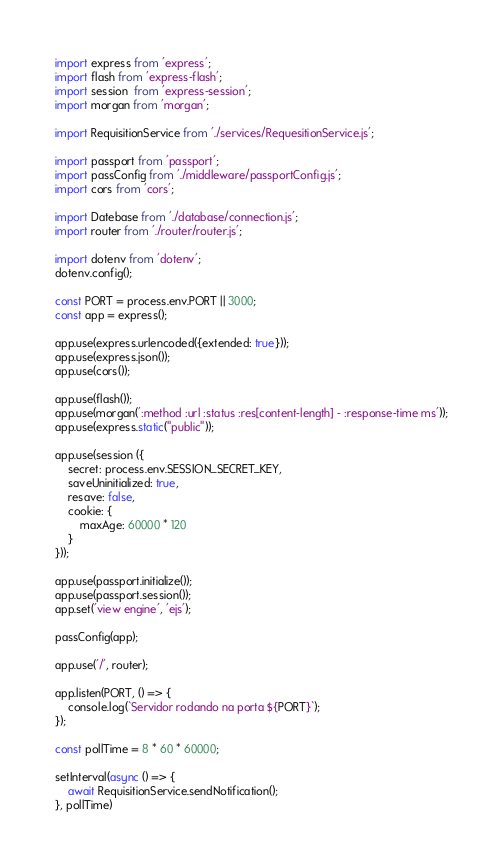<code> <loc_0><loc_0><loc_500><loc_500><_JavaScript_>import express from 'express';
import flash from 'express-flash';
import session  from 'express-session';
import morgan from 'morgan';

import RequisitionService from './services/RequesitionService.js';

import passport from 'passport';
import passConfig from './middleware/passportConfig.js';
import cors from 'cors';

import Datebase from './database/connection.js';
import router from './router/router.js';

import dotenv from 'dotenv';
dotenv.config();

const PORT = process.env.PORT || 3000;
const app = express();

app.use(express.urlencoded({extended: true}));
app.use(express.json());
app.use(cors());

app.use(flash());
app.use(morgan(':method :url :status :res[content-length] - :response-time ms'));
app.use(express.static("public"));

app.use(session ({
	secret: process.env.SESSION_SECRET_KEY,
	saveUninitialized: true,
	resave: false,
	cookie: {
		maxAge: 60000 * 120
	}
}));

app.use(passport.initialize());
app.use(passport.session());
app.set('view engine', 'ejs');

passConfig(app);

app.use('/', router);

app.listen(PORT, () => {
	console.log(`Servidor rodando na porta ${PORT}`);
});

const pollTime = 8 * 60 * 60000;

setInterval(async () => {
	await RequisitionService.sendNotification();
}, pollTime)
</code> 